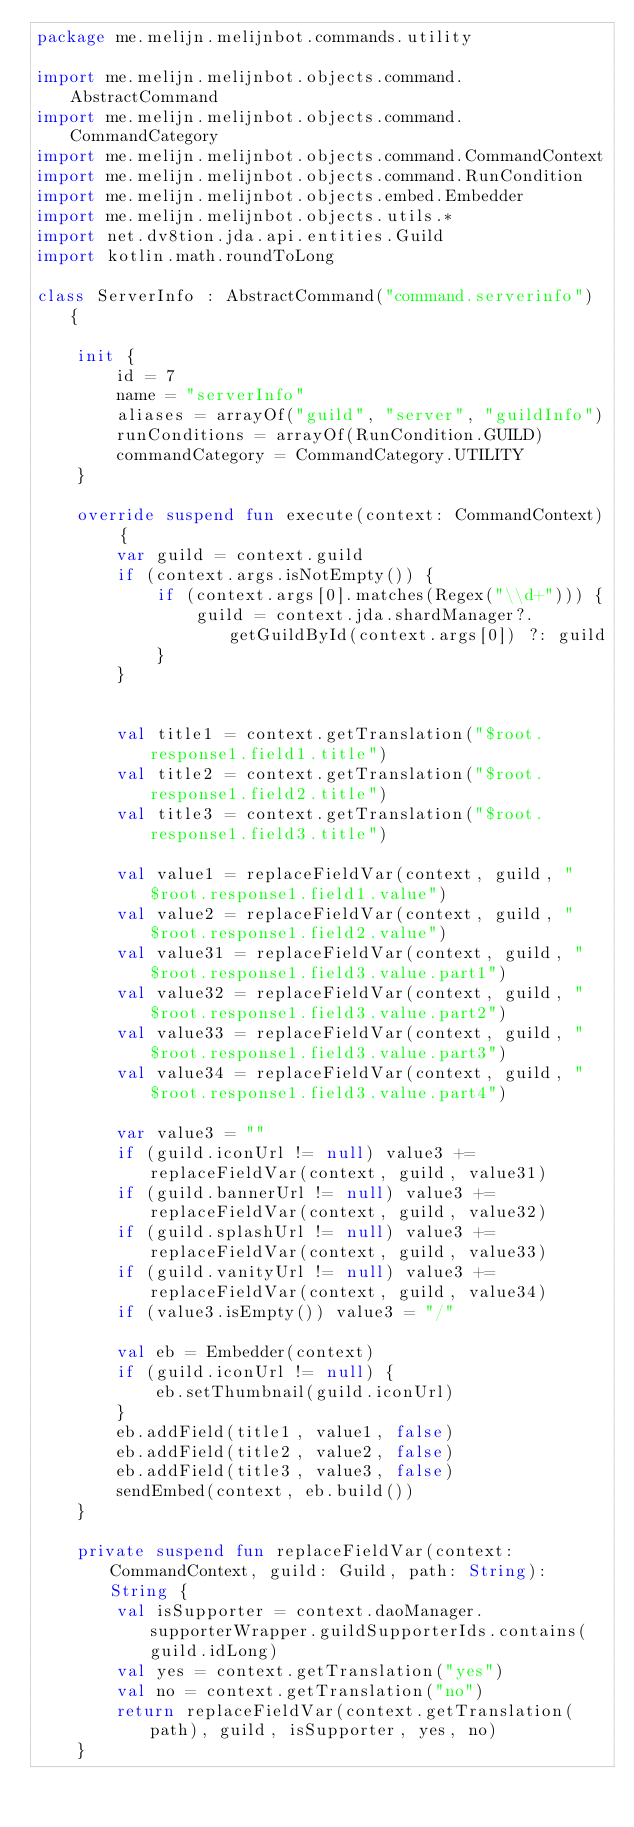<code> <loc_0><loc_0><loc_500><loc_500><_Kotlin_>package me.melijn.melijnbot.commands.utility

import me.melijn.melijnbot.objects.command.AbstractCommand
import me.melijn.melijnbot.objects.command.CommandCategory
import me.melijn.melijnbot.objects.command.CommandContext
import me.melijn.melijnbot.objects.command.RunCondition
import me.melijn.melijnbot.objects.embed.Embedder
import me.melijn.melijnbot.objects.utils.*
import net.dv8tion.jda.api.entities.Guild
import kotlin.math.roundToLong

class ServerInfo : AbstractCommand("command.serverinfo") {

    init {
        id = 7
        name = "serverInfo"
        aliases = arrayOf("guild", "server", "guildInfo")
        runConditions = arrayOf(RunCondition.GUILD)
        commandCategory = CommandCategory.UTILITY
    }

    override suspend fun execute(context: CommandContext) {
        var guild = context.guild
        if (context.args.isNotEmpty()) {
            if (context.args[0].matches(Regex("\\d+"))) {
                guild = context.jda.shardManager?.getGuildById(context.args[0]) ?: guild
            }
        }


        val title1 = context.getTranslation("$root.response1.field1.title")
        val title2 = context.getTranslation("$root.response1.field2.title")
        val title3 = context.getTranslation("$root.response1.field3.title")

        val value1 = replaceFieldVar(context, guild, "$root.response1.field1.value")
        val value2 = replaceFieldVar(context, guild, "$root.response1.field2.value")
        val value31 = replaceFieldVar(context, guild, "$root.response1.field3.value.part1")
        val value32 = replaceFieldVar(context, guild, "$root.response1.field3.value.part2")
        val value33 = replaceFieldVar(context, guild, "$root.response1.field3.value.part3")
        val value34 = replaceFieldVar(context, guild, "$root.response1.field3.value.part4")

        var value3 = ""
        if (guild.iconUrl != null) value3 += replaceFieldVar(context, guild, value31)
        if (guild.bannerUrl != null) value3 += replaceFieldVar(context, guild, value32)
        if (guild.splashUrl != null) value3 += replaceFieldVar(context, guild, value33)
        if (guild.vanityUrl != null) value3 += replaceFieldVar(context, guild, value34)
        if (value3.isEmpty()) value3 = "/"

        val eb = Embedder(context)
        if (guild.iconUrl != null) {
            eb.setThumbnail(guild.iconUrl)
        }
        eb.addField(title1, value1, false)
        eb.addField(title2, value2, false)
        eb.addField(title3, value3, false)
        sendEmbed(context, eb.build())
    }

    private suspend fun replaceFieldVar(context: CommandContext, guild: Guild, path: String): String {
        val isSupporter = context.daoManager.supporterWrapper.guildSupporterIds.contains(guild.idLong)
        val yes = context.getTranslation("yes")
        val no = context.getTranslation("no")
        return replaceFieldVar(context.getTranslation(path), guild, isSupporter, yes, no)
    }
</code> 